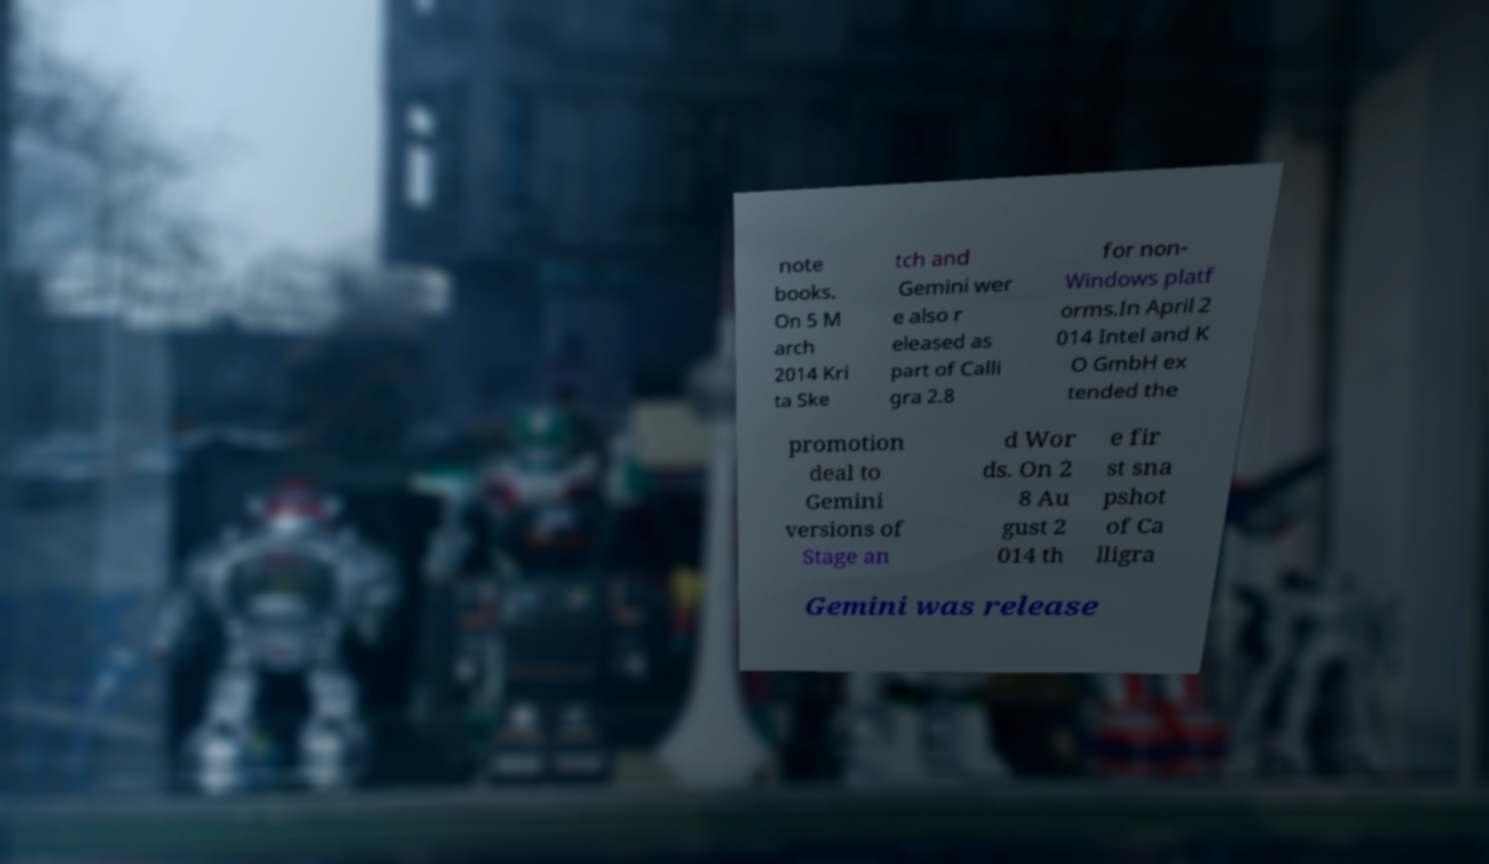Could you extract and type out the text from this image? note books. On 5 M arch 2014 Kri ta Ske tch and Gemini wer e also r eleased as part of Calli gra 2.8 for non- Windows platf orms.In April 2 014 Intel and K O GmbH ex tended the promotion deal to Gemini versions of Stage an d Wor ds. On 2 8 Au gust 2 014 th e fir st sna pshot of Ca lligra Gemini was release 